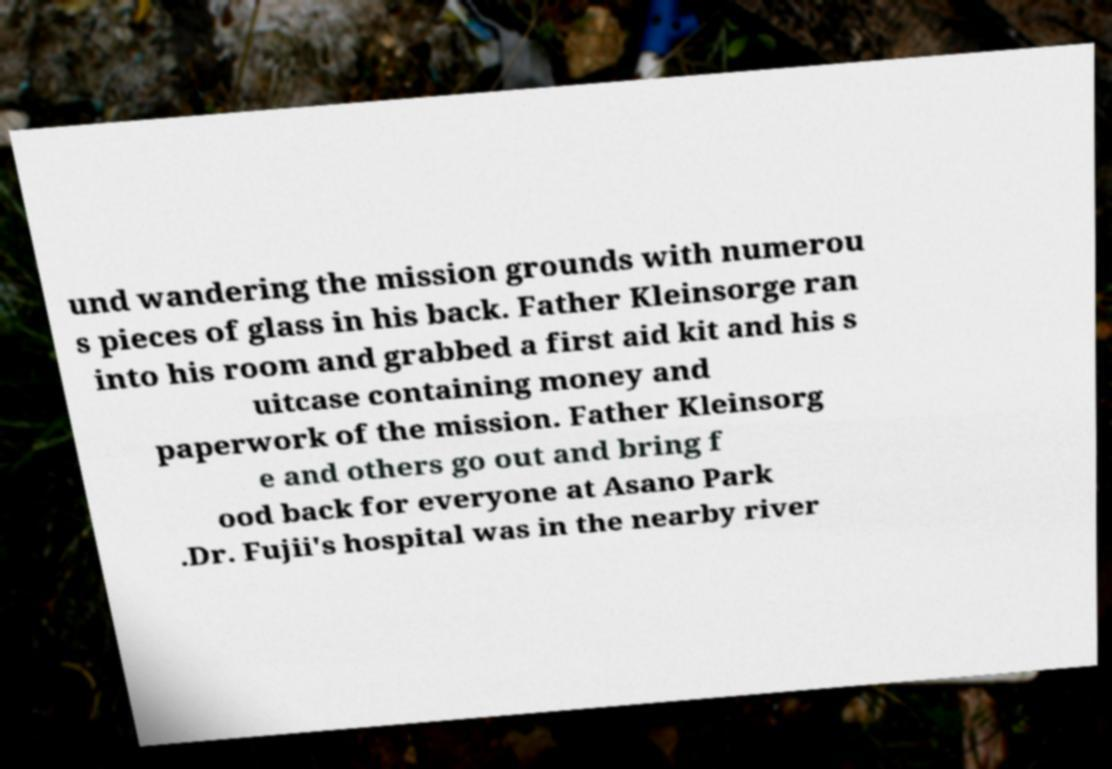What messages or text are displayed in this image? I need them in a readable, typed format. und wandering the mission grounds with numerou s pieces of glass in his back. Father Kleinsorge ran into his room and grabbed a first aid kit and his s uitcase containing money and paperwork of the mission. Father Kleinsorg e and others go out and bring f ood back for everyone at Asano Park .Dr. Fujii's hospital was in the nearby river 